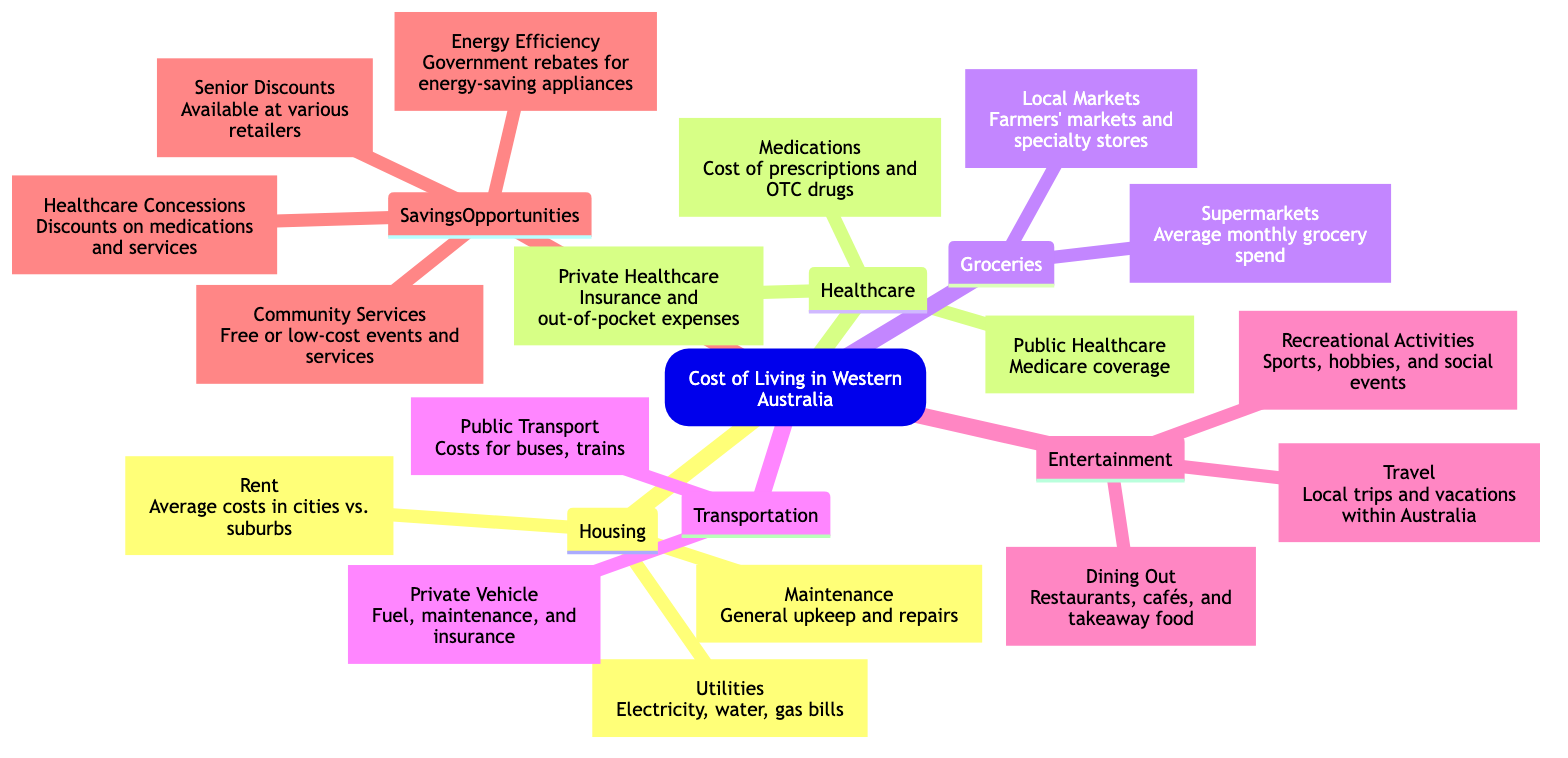What are the main categories of expenses in the cost of living? The diagram shows five main categories under the root "Cost of Living in Western Australia": Housing, Healthcare, Groceries, Transportation, and Entertainment.
Answer: Housing, Healthcare, Groceries, Transportation, Entertainment How many types of savings opportunities are listed? Under the "Savings Opportunities" node, there are four types mentioned: Senior Discounts, Community Services, Energy Efficiency, and Healthcare Concessions.
Answer: Four What is covered under Public Healthcare? The "Public Healthcare" child node under "Healthcare" mentions that it includes Medicare coverage.
Answer: Medicare coverage Which type of transportation expenses involve costs for buses and trains? The "Public Transport" child node under "Transportation" specifies costs for buses and trains, thus detailing one of the types of transportation expenses.
Answer: Public Transport How do medications relate to healthcare expenses? The "Medications" child node under "Healthcare" details the costs for prescriptions and over-the-counter drugs, showing its relationship to healthcare expenses.
Answer: Cost of prescriptions and OTC drugs What is a significant factor to consider in Rent costs? The "Rent" child node under "Housing" mentions average costs in cities versus suburbs, indicating a significant factor to consider.
Answer: Average costs in cities vs. suburbs What kind of discounts can seniors benefit from? The "Senior Discounts" child node under "Savings Opportunities" states that these are available at various retailers, public transport, and utilities, giving seniors multiple areas for potential savings.
Answer: Available at various retailers Which category encompasses dining out and recreational activities? The "Entertainment" category includes both "Dining Out" and "Recreational Activities" as part of its sub-nodes, showing that these are elements of entertainment expenses.
Answer: Entertainment What potential savings opportunities relate to energy efficiency? The "Energy Efficiency" child node under "Savings Opportunities" refers to government rebates for energy-saving appliances, identifying the link to energy efficiency.
Answer: Government rebates for energy-saving appliances 